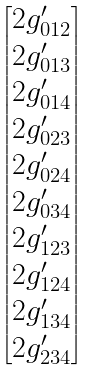<formula> <loc_0><loc_0><loc_500><loc_500>\begin{bmatrix} 2 g ^ { \prime } _ { 0 1 2 } \\ 2 g ^ { \prime } _ { 0 1 3 } \\ 2 g ^ { \prime } _ { 0 1 4 } \\ 2 g ^ { \prime } _ { 0 2 3 } \\ 2 g ^ { \prime } _ { 0 2 4 } \\ 2 g ^ { \prime } _ { 0 3 4 } \\ 2 g ^ { \prime } _ { 1 2 3 } \\ 2 g ^ { \prime } _ { 1 2 4 } \\ 2 g ^ { \prime } _ { 1 3 4 } \\ 2 g ^ { \prime } _ { 2 3 4 } \\ \end{bmatrix}</formula> 